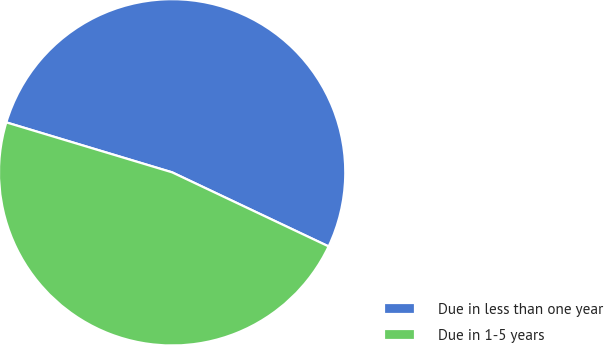Convert chart. <chart><loc_0><loc_0><loc_500><loc_500><pie_chart><fcel>Due in less than one year<fcel>Due in 1-5 years<nl><fcel>52.38%<fcel>47.62%<nl></chart> 